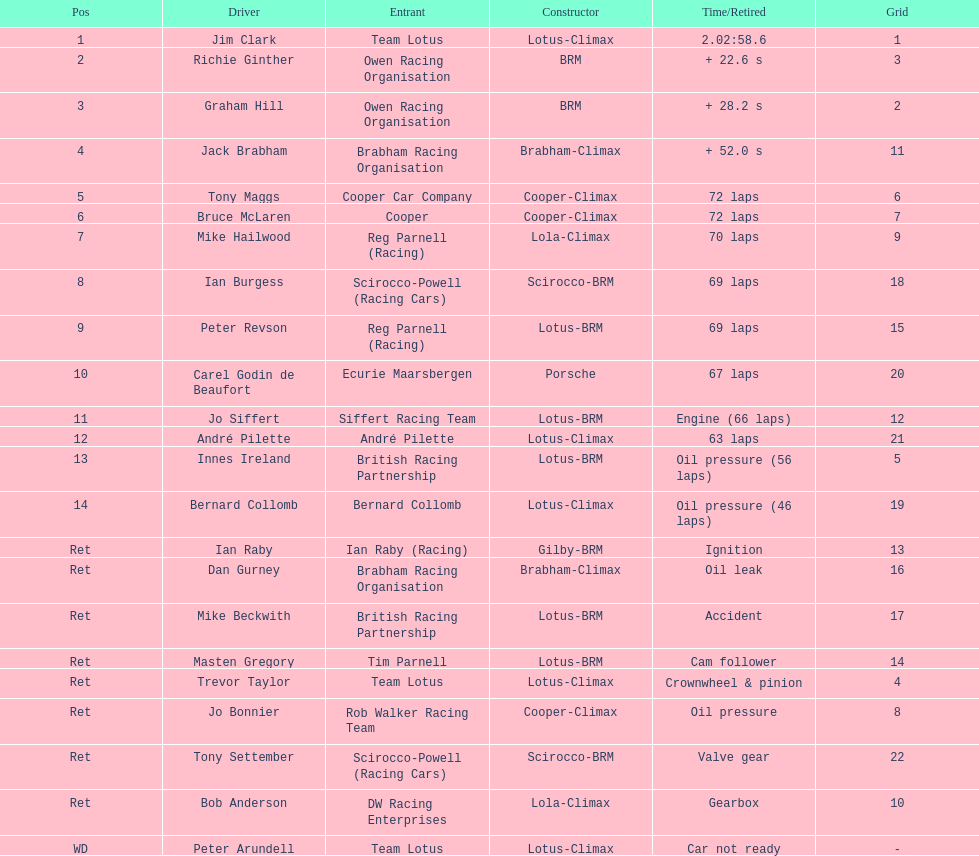What is the number of americans in the top 5? 1. 